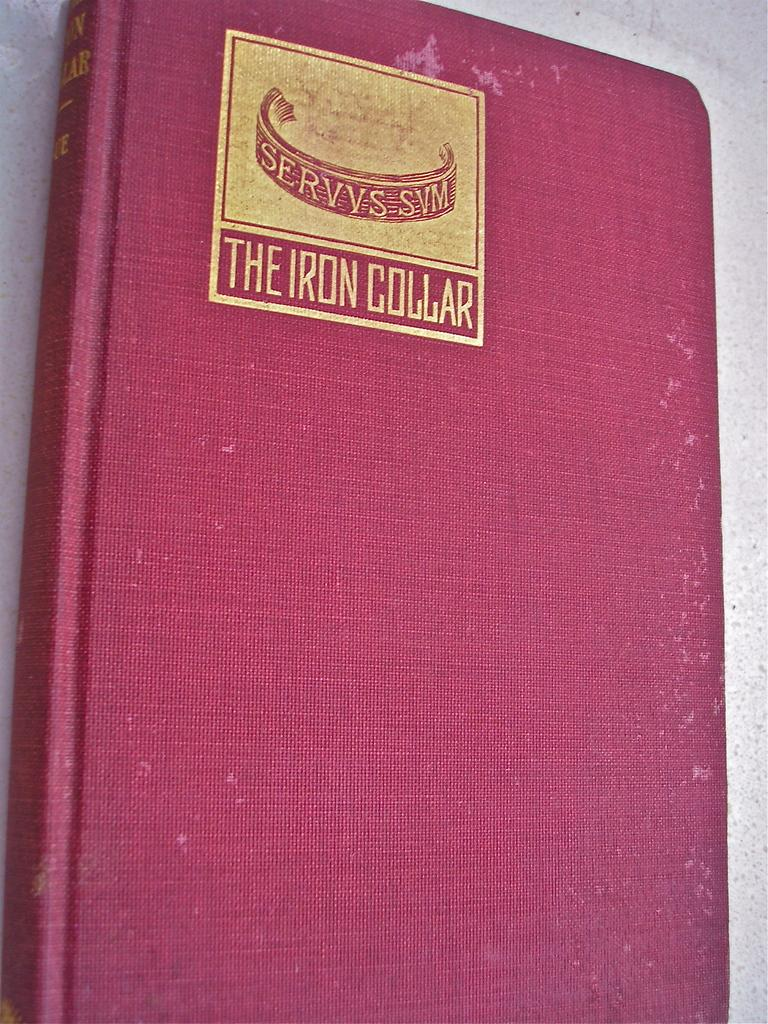<image>
Offer a succinct explanation of the picture presented. the cover of a pink book is named The Iron Collar 